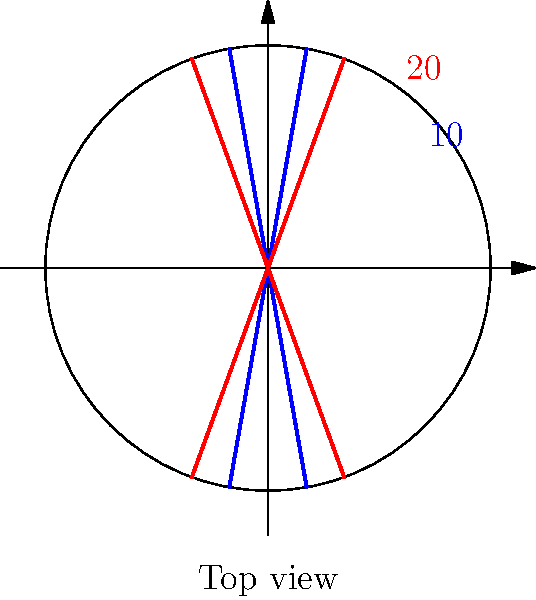In racing wheelchair design, wheel camber angles play a crucial role in performance. The diagram shows two different camber angles: 10° (blue) and 20° (red). Based on your experience and knowledge of Paralympic racing, which camber angle is generally considered optimal for maximizing speed and stability on a standard track? To determine the optimal wheel camber angle for racing wheelchairs, we need to consider several factors:

1. Stability: A larger camber angle increases stability by widening the wheelchair's base.
2. Turning ability: A larger camber angle improves turning performance by allowing for a tighter turning radius.
3. Push efficiency: A moderate camber angle allows for a more ergonomic push rim position, reducing shoulder strain.
4. Rolling resistance: As camber angle increases, rolling resistance also increases due to increased friction with the ground.
5. Aerodynamics: A larger camber angle can increase air resistance, potentially reducing top speed.

Considering these factors:
- A 10° camber angle provides a good balance between stability and rolling resistance.
- A 20° camber angle offers excellent stability and turning ability but increases rolling resistance and air drag.

For most Paralympic racing events on a standard track, the optimal camber angle is typically between 10° and 15°. This range provides a good balance of stability, turning ability, and push efficiency while minimizing rolling resistance and aerodynamic drag.

Therefore, in this comparison, the 10° camber angle (blue) is generally considered more optimal for maximizing speed and stability on a standard track.
Answer: 10° 